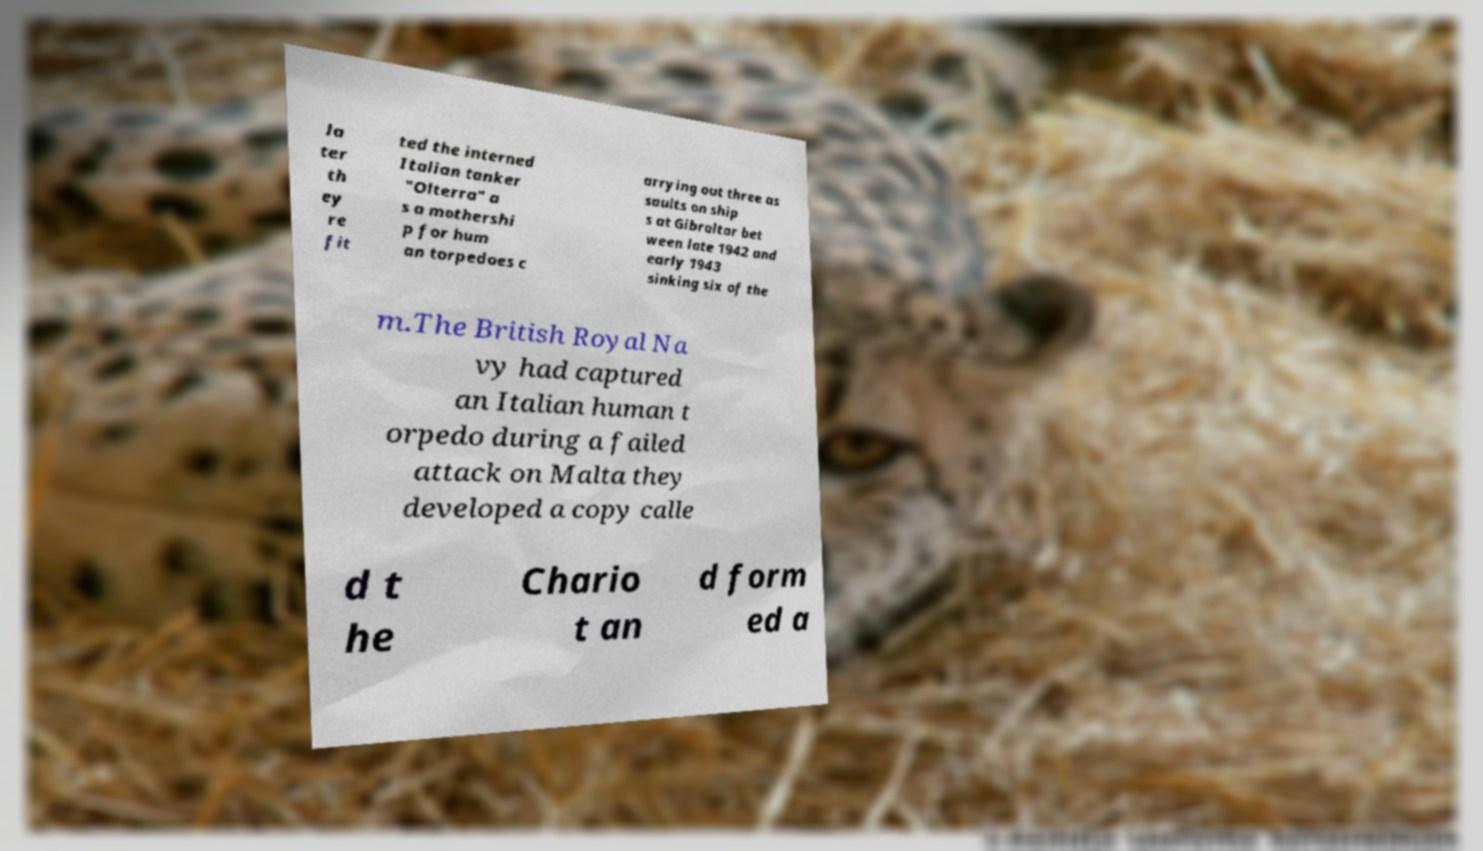I need the written content from this picture converted into text. Can you do that? la ter th ey re fit ted the interned Italian tanker "Olterra" a s a mothershi p for hum an torpedoes c arrying out three as saults on ship s at Gibraltar bet ween late 1942 and early 1943 sinking six of the m.The British Royal Na vy had captured an Italian human t orpedo during a failed attack on Malta they developed a copy calle d t he Chario t an d form ed a 